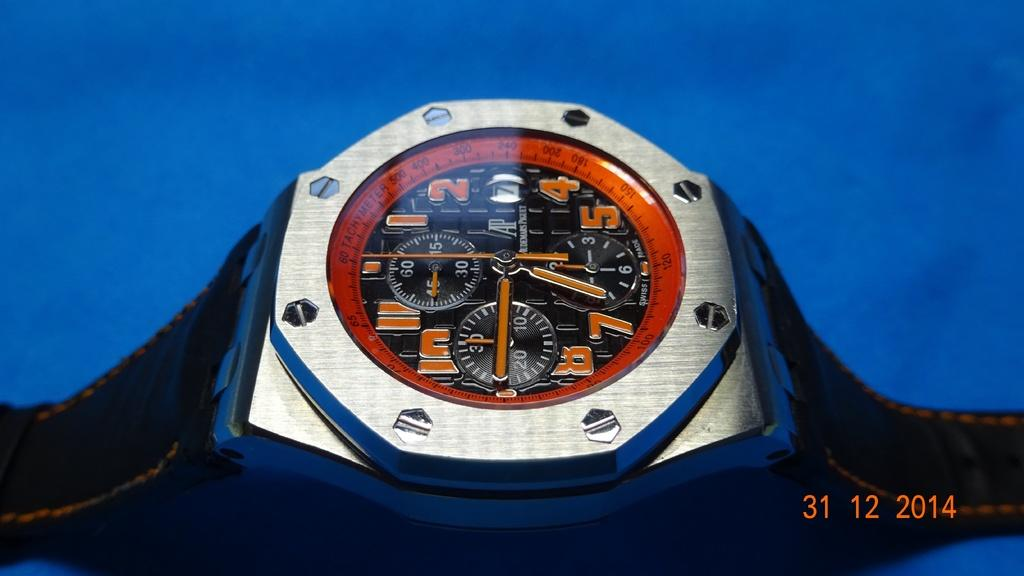Provide a one-sentence caption for the provided image. A busy watch face tells the time at around 6:45. 